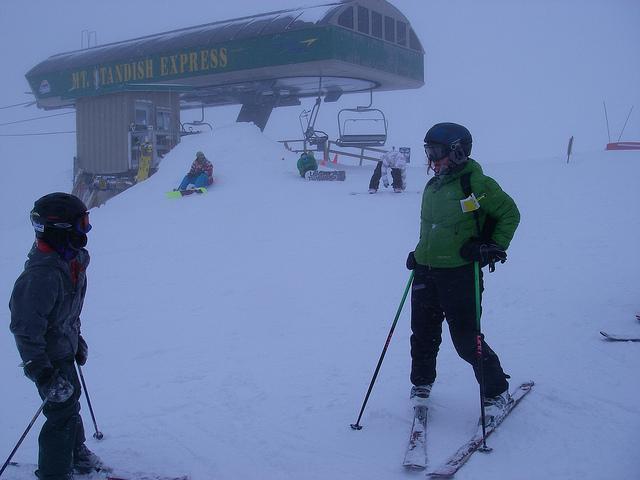How many people are in the photo?
Give a very brief answer. 2. How many horses have white on them?
Give a very brief answer. 0. 